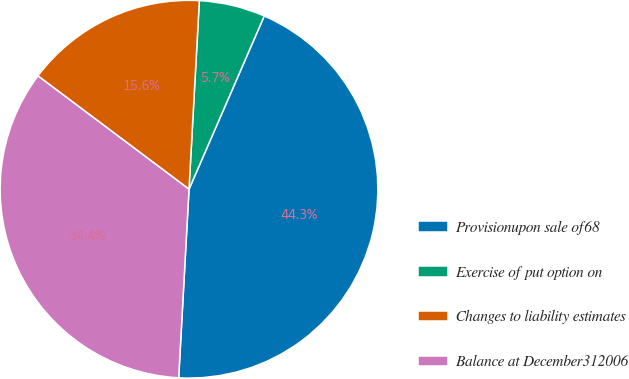Convert chart to OTSL. <chart><loc_0><loc_0><loc_500><loc_500><pie_chart><fcel>Provisionupon sale of68<fcel>Exercise of put option on<fcel>Changes to liability estimates<fcel>Balance at December312006<nl><fcel>44.35%<fcel>5.65%<fcel>15.63%<fcel>34.37%<nl></chart> 